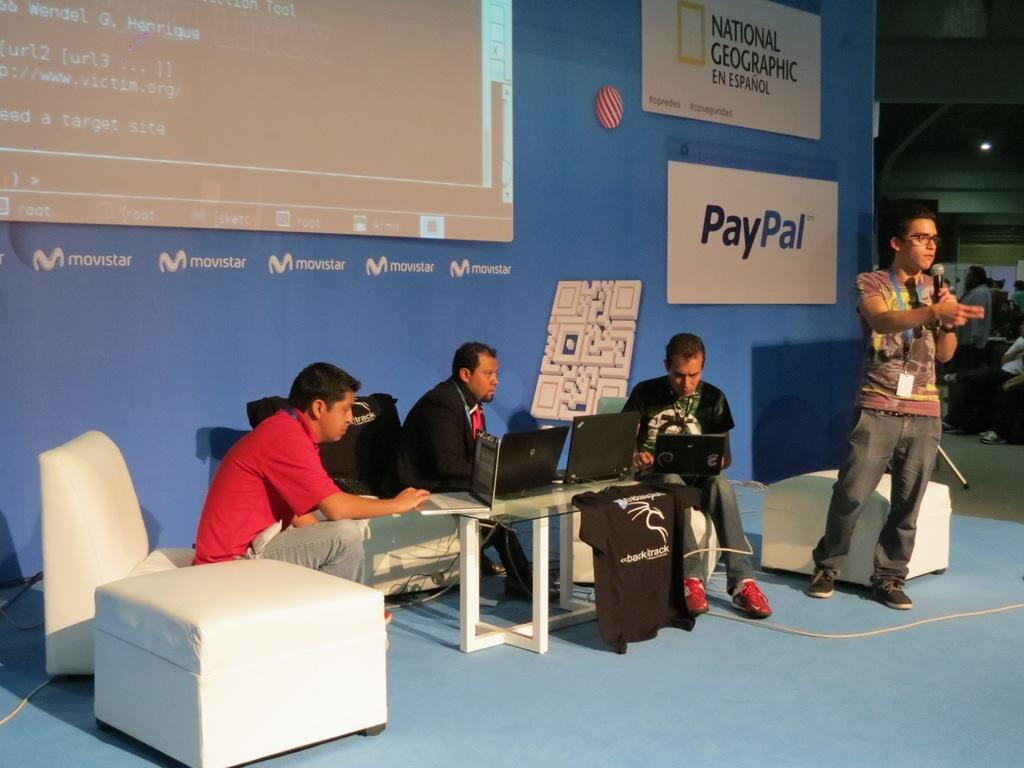How many people are sitting on sofa chairs in the image? There are 3 people sitting on sofa chairs in the image. What are the people sitting on sofa chairs doing? The people sitting on sofa chairs are working on their laptops. Is there anyone standing in the image? Yes, there is a person standing in the image. What is the standing person doing? The standing person is talking into a microphone. What type of vest is the judge wearing in the image? There is no judge or vest present in the image. What is the standing person's lip expression while talking into the microphone? The image does not provide enough detail to determine the standing person's lip expression while talking into the microphone. 